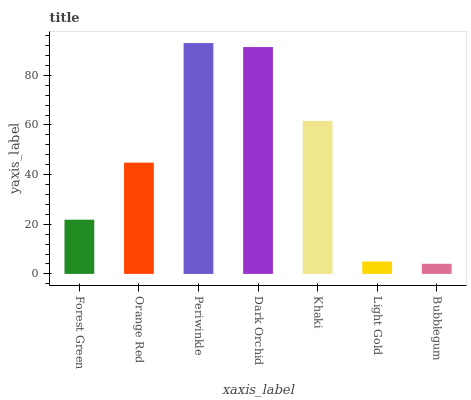Is Bubblegum the minimum?
Answer yes or no. Yes. Is Periwinkle the maximum?
Answer yes or no. Yes. Is Orange Red the minimum?
Answer yes or no. No. Is Orange Red the maximum?
Answer yes or no. No. Is Orange Red greater than Forest Green?
Answer yes or no. Yes. Is Forest Green less than Orange Red?
Answer yes or no. Yes. Is Forest Green greater than Orange Red?
Answer yes or no. No. Is Orange Red less than Forest Green?
Answer yes or no. No. Is Orange Red the high median?
Answer yes or no. Yes. Is Orange Red the low median?
Answer yes or no. Yes. Is Periwinkle the high median?
Answer yes or no. No. Is Bubblegum the low median?
Answer yes or no. No. 